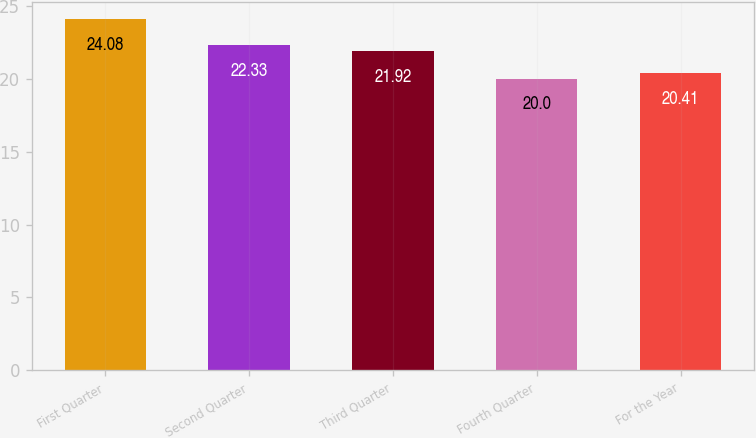Convert chart. <chart><loc_0><loc_0><loc_500><loc_500><bar_chart><fcel>First Quarter<fcel>Second Quarter<fcel>Third Quarter<fcel>Fourth Quarter<fcel>For the Year<nl><fcel>24.08<fcel>22.33<fcel>21.92<fcel>20<fcel>20.41<nl></chart> 